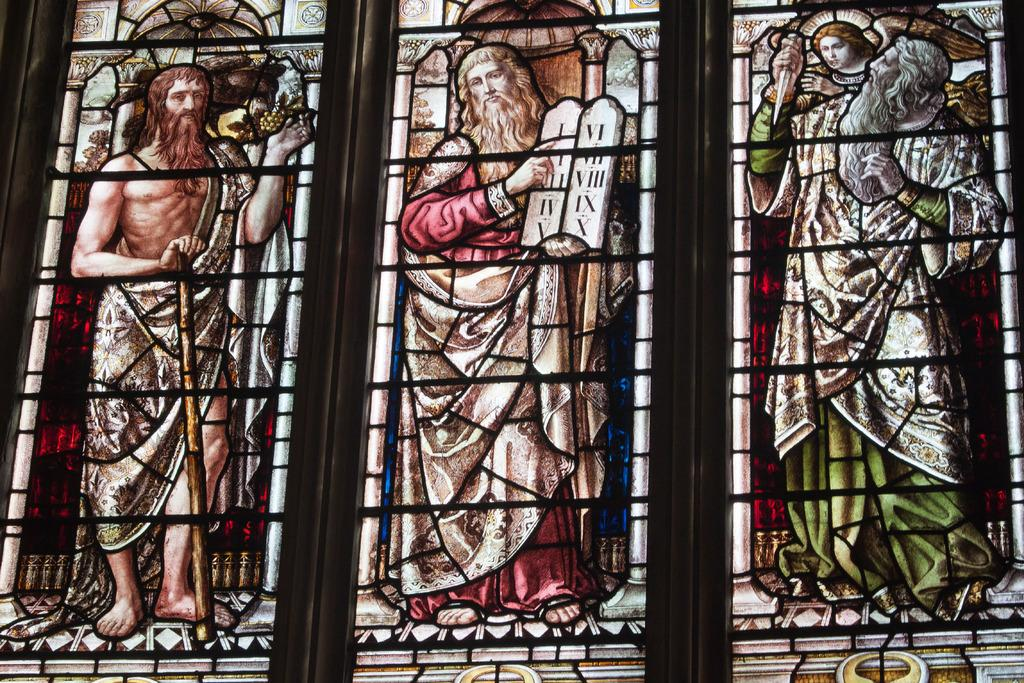What type of material is used for the windows in the image? The windows in the image are made of glass. What can be seen on the glass windows? There are paintings of men on the windows. What is the title of the painting on the feet in the image? There are no feet or titles mentioned in the provided facts, as the image only features glass windows with paintings of men on them. 